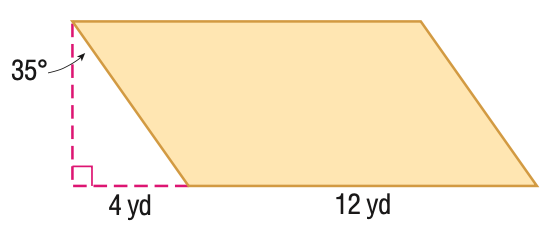Answer the mathemtical geometry problem and directly provide the correct option letter.
Question: Find the perimeter of the figure. Round to the nearest hundredth, if necessary.
Choices: A: 32 B: 33.8 C: 35.4 D: 37.9 D 